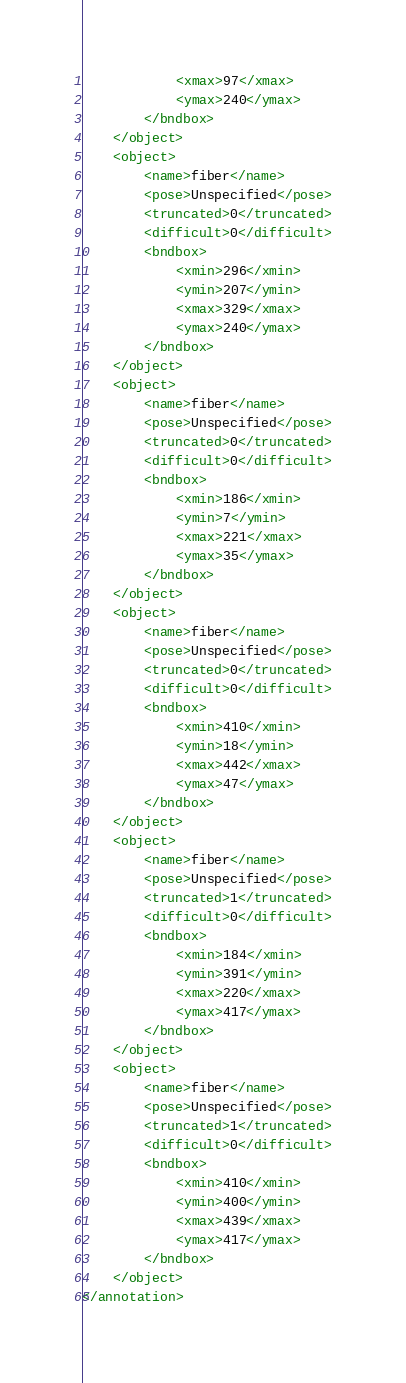Convert code to text. <code><loc_0><loc_0><loc_500><loc_500><_XML_>			<xmax>97</xmax>
			<ymax>240</ymax>
		</bndbox>
	</object>
	<object>
		<name>fiber</name>
		<pose>Unspecified</pose>
		<truncated>0</truncated>
		<difficult>0</difficult>
		<bndbox>
			<xmin>296</xmin>
			<ymin>207</ymin>
			<xmax>329</xmax>
			<ymax>240</ymax>
		</bndbox>
	</object>
	<object>
		<name>fiber</name>
		<pose>Unspecified</pose>
		<truncated>0</truncated>
		<difficult>0</difficult>
		<bndbox>
			<xmin>186</xmin>
			<ymin>7</ymin>
			<xmax>221</xmax>
			<ymax>35</ymax>
		</bndbox>
	</object>
	<object>
		<name>fiber</name>
		<pose>Unspecified</pose>
		<truncated>0</truncated>
		<difficult>0</difficult>
		<bndbox>
			<xmin>410</xmin>
			<ymin>18</ymin>
			<xmax>442</xmax>
			<ymax>47</ymax>
		</bndbox>
	</object>
	<object>
		<name>fiber</name>
		<pose>Unspecified</pose>
		<truncated>1</truncated>
		<difficult>0</difficult>
		<bndbox>
			<xmin>184</xmin>
			<ymin>391</ymin>
			<xmax>220</xmax>
			<ymax>417</ymax>
		</bndbox>
	</object>
	<object>
		<name>fiber</name>
		<pose>Unspecified</pose>
		<truncated>1</truncated>
		<difficult>0</difficult>
		<bndbox>
			<xmin>410</xmin>
			<ymin>400</ymin>
			<xmax>439</xmax>
			<ymax>417</ymax>
		</bndbox>
	</object>
</annotation>
</code> 